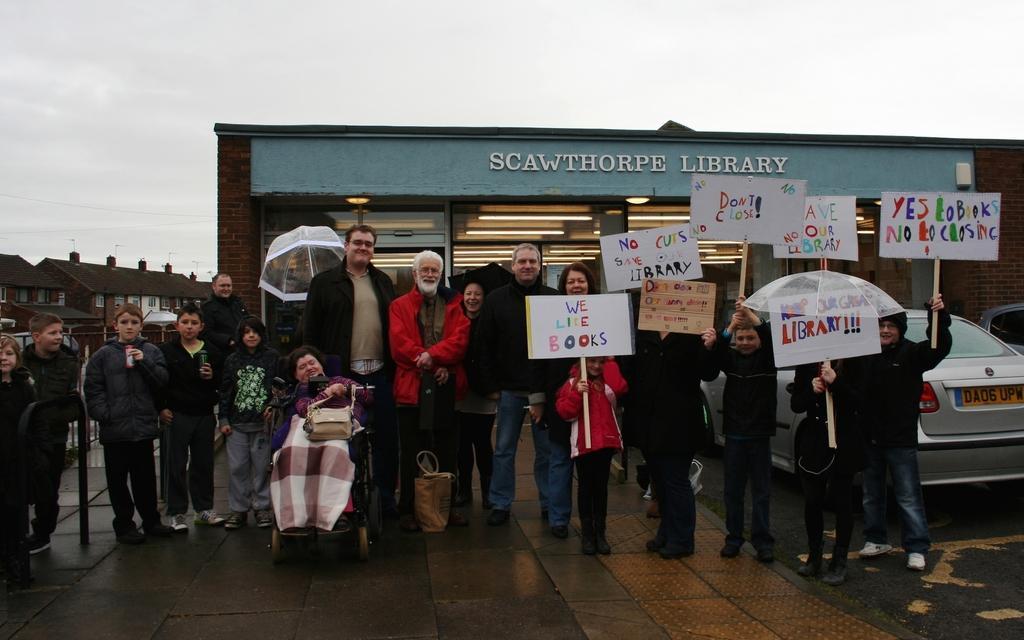Could you give a brief overview of what you see in this image? In this image we can see some people and among them some are holding boards and there is some text on it and to the side, we can see a car. In the background, we can see some building and the sky. 